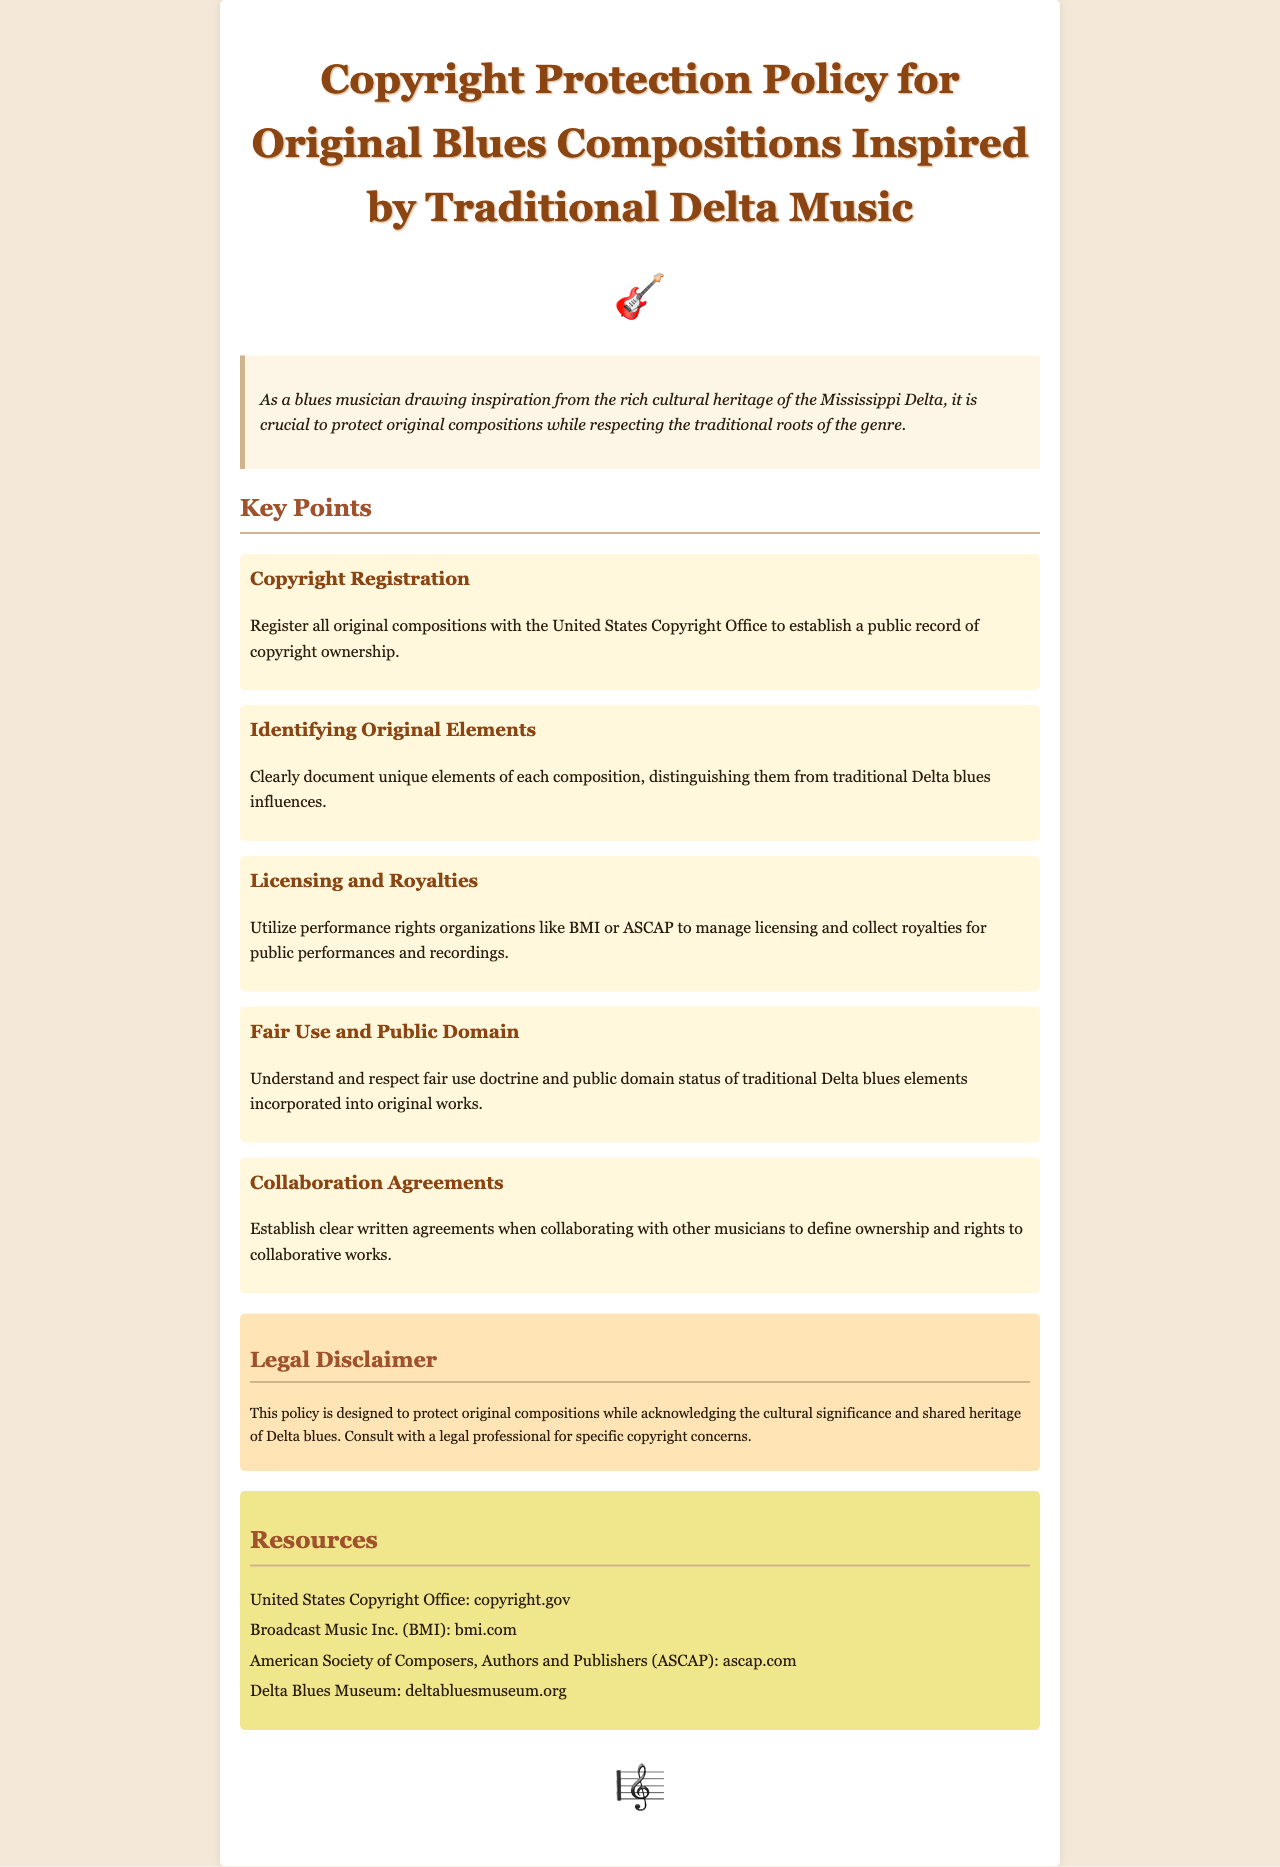What is the title of the document? The title is stated at the beginning of the document, indicating its focus on copyright protection for a specific genre of music.
Answer: Copyright Protection Policy for Original Blues Compositions Inspired by Traditional Delta Music What is the first key point listed in the document? The first key point is explicitly mentioned in the section detailing important aspects of copyright protection for music composition.
Answer: Copyright Registration Which organization is mentioned for managing licensing? This organization is referenced in relation to helping musicians facilitate the licensing process for their performances.
Answer: BMI What does the legal disclaimer highlight? The legal disclaimer summarizes the intent of the policy and suggests a course of action for specific copyright concerns.
Answer: Consult with a legal professional How many resources are listed in the document? The number of resources can be determined by counting the list items under the Resources section.
Answer: Four 